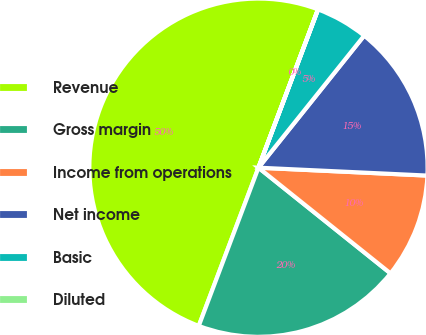Convert chart to OTSL. <chart><loc_0><loc_0><loc_500><loc_500><pie_chart><fcel>Revenue<fcel>Gross margin<fcel>Income from operations<fcel>Net income<fcel>Basic<fcel>Diluted<nl><fcel>49.98%<fcel>20.0%<fcel>10.0%<fcel>15.0%<fcel>5.01%<fcel>0.01%<nl></chart> 